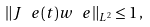<formula> <loc_0><loc_0><loc_500><loc_500>\| J ^ { \ } e ( t ) w ^ { \ } e \| _ { L ^ { 2 } } \leq 1 \, ,</formula> 